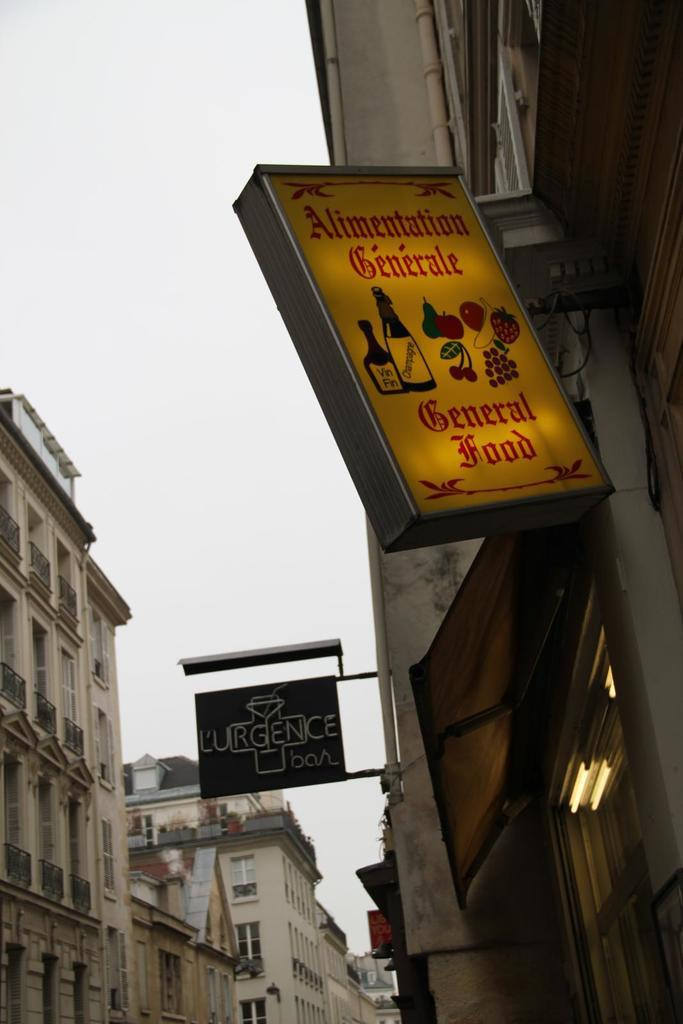<image>
Offer a succinct explanation of the picture presented. A lighted sign that says Alimentation Generale General Food. 